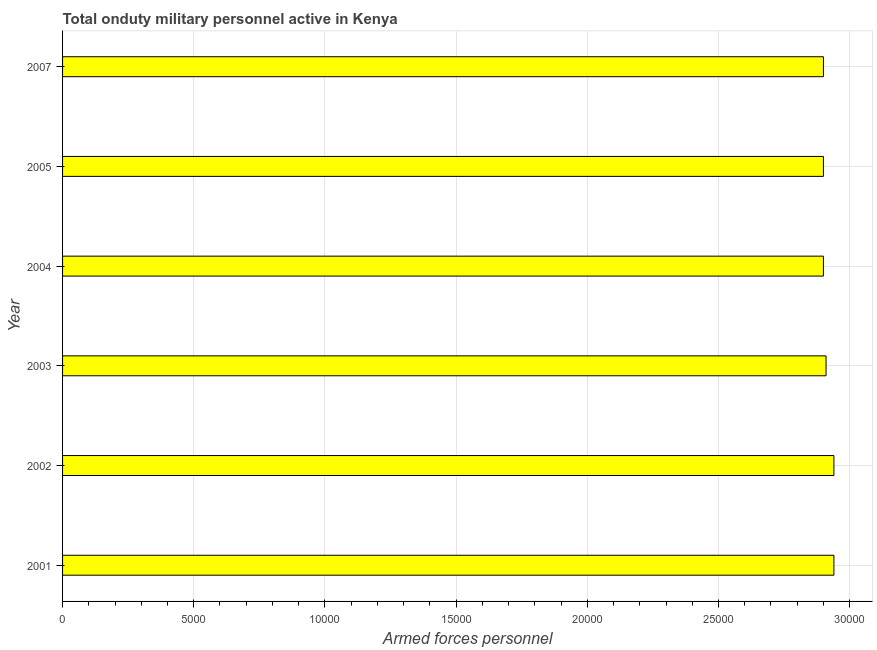What is the title of the graph?
Keep it short and to the point. Total onduty military personnel active in Kenya. What is the label or title of the X-axis?
Make the answer very short. Armed forces personnel. What is the label or title of the Y-axis?
Provide a succinct answer. Year. What is the number of armed forces personnel in 2005?
Offer a terse response. 2.90e+04. Across all years, what is the maximum number of armed forces personnel?
Offer a very short reply. 2.94e+04. Across all years, what is the minimum number of armed forces personnel?
Provide a short and direct response. 2.90e+04. In which year was the number of armed forces personnel minimum?
Give a very brief answer. 2004. What is the sum of the number of armed forces personnel?
Ensure brevity in your answer.  1.75e+05. What is the average number of armed forces personnel per year?
Your response must be concise. 2.92e+04. What is the median number of armed forces personnel?
Give a very brief answer. 2.90e+04. What is the ratio of the number of armed forces personnel in 2002 to that in 2005?
Give a very brief answer. 1.01. Is the sum of the number of armed forces personnel in 2003 and 2004 greater than the maximum number of armed forces personnel across all years?
Your answer should be very brief. Yes. Are all the bars in the graph horizontal?
Your answer should be compact. Yes. What is the difference between two consecutive major ticks on the X-axis?
Make the answer very short. 5000. Are the values on the major ticks of X-axis written in scientific E-notation?
Offer a very short reply. No. What is the Armed forces personnel of 2001?
Offer a terse response. 2.94e+04. What is the Armed forces personnel in 2002?
Your answer should be compact. 2.94e+04. What is the Armed forces personnel of 2003?
Offer a terse response. 2.91e+04. What is the Armed forces personnel in 2004?
Give a very brief answer. 2.90e+04. What is the Armed forces personnel of 2005?
Offer a terse response. 2.90e+04. What is the Armed forces personnel of 2007?
Provide a short and direct response. 2.90e+04. What is the difference between the Armed forces personnel in 2001 and 2002?
Make the answer very short. 0. What is the difference between the Armed forces personnel in 2001 and 2003?
Offer a terse response. 300. What is the difference between the Armed forces personnel in 2001 and 2004?
Make the answer very short. 400. What is the difference between the Armed forces personnel in 2001 and 2005?
Give a very brief answer. 400. What is the difference between the Armed forces personnel in 2001 and 2007?
Make the answer very short. 400. What is the difference between the Armed forces personnel in 2002 and 2003?
Give a very brief answer. 300. What is the difference between the Armed forces personnel in 2002 and 2004?
Provide a succinct answer. 400. What is the difference between the Armed forces personnel in 2002 and 2007?
Your answer should be compact. 400. What is the difference between the Armed forces personnel in 2003 and 2004?
Keep it short and to the point. 100. What is the difference between the Armed forces personnel in 2004 and 2005?
Provide a succinct answer. 0. What is the difference between the Armed forces personnel in 2004 and 2007?
Provide a succinct answer. 0. What is the difference between the Armed forces personnel in 2005 and 2007?
Keep it short and to the point. 0. What is the ratio of the Armed forces personnel in 2001 to that in 2002?
Your answer should be compact. 1. What is the ratio of the Armed forces personnel in 2001 to that in 2003?
Offer a terse response. 1.01. What is the ratio of the Armed forces personnel in 2001 to that in 2005?
Offer a terse response. 1.01. What is the ratio of the Armed forces personnel in 2002 to that in 2003?
Provide a succinct answer. 1.01. What is the ratio of the Armed forces personnel in 2003 to that in 2007?
Your response must be concise. 1. What is the ratio of the Armed forces personnel in 2004 to that in 2005?
Give a very brief answer. 1. What is the ratio of the Armed forces personnel in 2004 to that in 2007?
Make the answer very short. 1. 